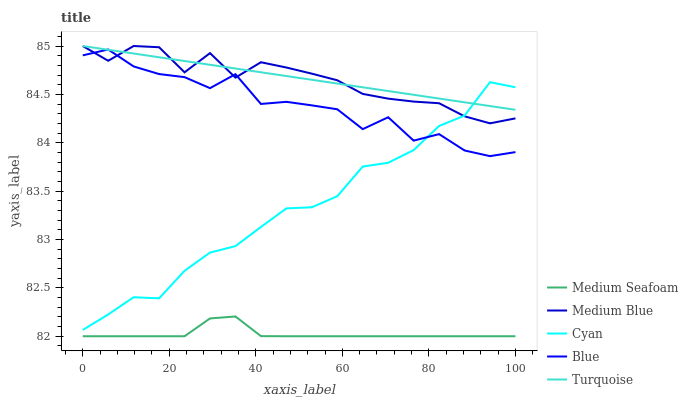Does Medium Seafoam have the minimum area under the curve?
Answer yes or no. Yes. Does Turquoise have the maximum area under the curve?
Answer yes or no. Yes. Does Cyan have the minimum area under the curve?
Answer yes or no. No. Does Cyan have the maximum area under the curve?
Answer yes or no. No. Is Turquoise the smoothest?
Answer yes or no. Yes. Is Blue the roughest?
Answer yes or no. Yes. Is Cyan the smoothest?
Answer yes or no. No. Is Cyan the roughest?
Answer yes or no. No. Does Medium Seafoam have the lowest value?
Answer yes or no. Yes. Does Cyan have the lowest value?
Answer yes or no. No. Does Medium Blue have the highest value?
Answer yes or no. Yes. Does Cyan have the highest value?
Answer yes or no. No. Is Medium Seafoam less than Turquoise?
Answer yes or no. Yes. Is Blue greater than Medium Seafoam?
Answer yes or no. Yes. Does Turquoise intersect Cyan?
Answer yes or no. Yes. Is Turquoise less than Cyan?
Answer yes or no. No. Is Turquoise greater than Cyan?
Answer yes or no. No. Does Medium Seafoam intersect Turquoise?
Answer yes or no. No. 